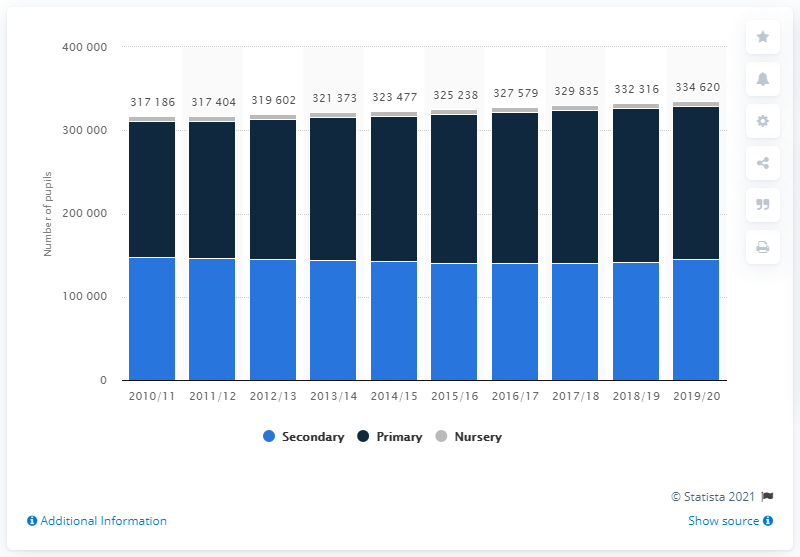Draw attention to some important aspects in this diagram. In the 2019-2020 school year, there were approximately 183,711 primary school students in Northern Ireland. 